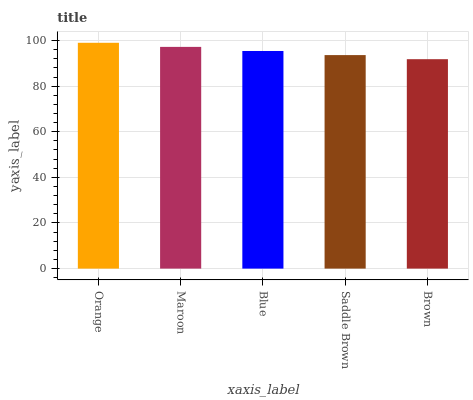Is Maroon the minimum?
Answer yes or no. No. Is Maroon the maximum?
Answer yes or no. No. Is Orange greater than Maroon?
Answer yes or no. Yes. Is Maroon less than Orange?
Answer yes or no. Yes. Is Maroon greater than Orange?
Answer yes or no. No. Is Orange less than Maroon?
Answer yes or no. No. Is Blue the high median?
Answer yes or no. Yes. Is Blue the low median?
Answer yes or no. Yes. Is Orange the high median?
Answer yes or no. No. Is Orange the low median?
Answer yes or no. No. 